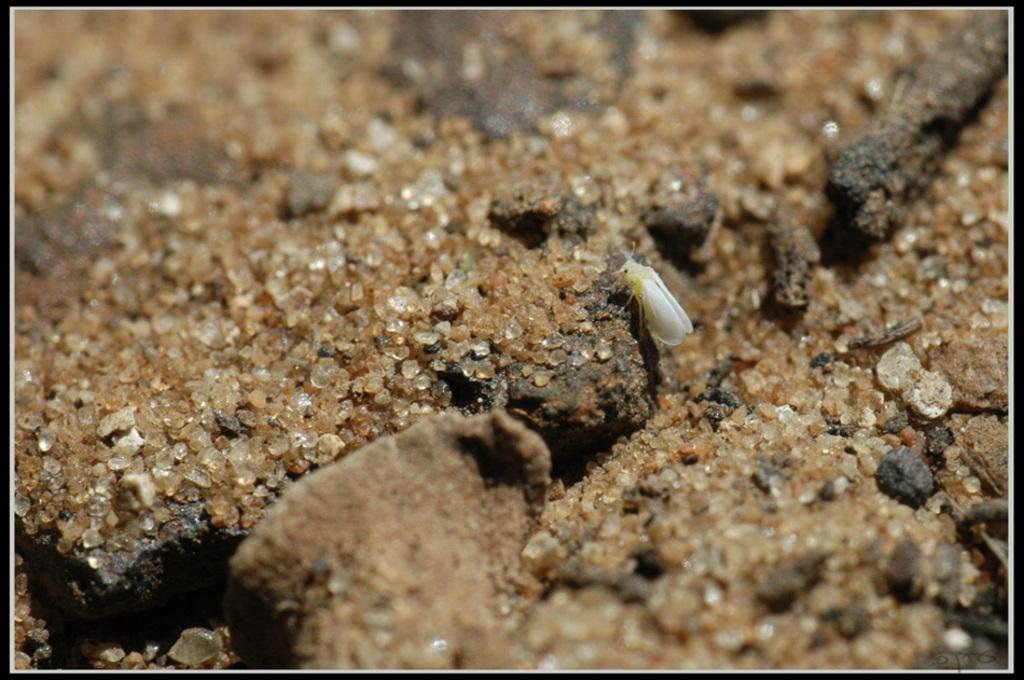What type of insect is visible in the image? There is a white insect in the image. What is the insect standing near? The insect is standing near sand. What can be seen on the left side of the image? There are sandstones on the left side of the image. What type of square object can be seen in the image? There is no square object present in the image; it features a white insect standing near sand with sandstones on the left side. What type of flesh is visible on the insect in the image? There is no visible flesh on the insect in the image, as it is a white insect with no discernible features other than its color. 